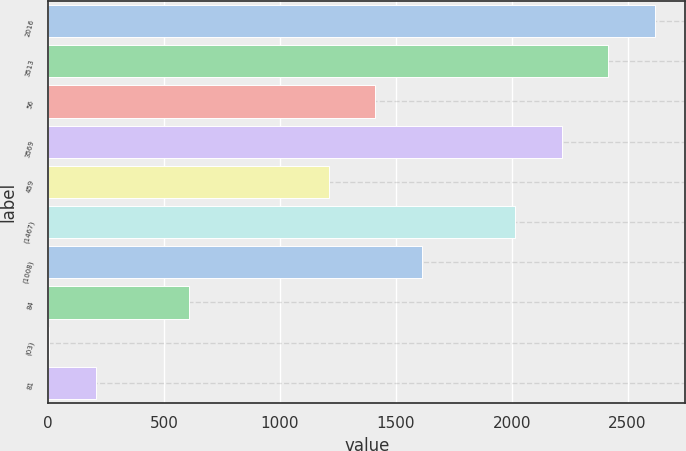Convert chart. <chart><loc_0><loc_0><loc_500><loc_500><bar_chart><fcel>2016<fcel>3513<fcel>56<fcel>3569<fcel>459<fcel>(1467)<fcel>(1008)<fcel>84<fcel>(03)<fcel>81<nl><fcel>2618.51<fcel>2417.34<fcel>1411.49<fcel>2216.17<fcel>1210.32<fcel>2015<fcel>1612.66<fcel>606.81<fcel>3.3<fcel>204.47<nl></chart> 